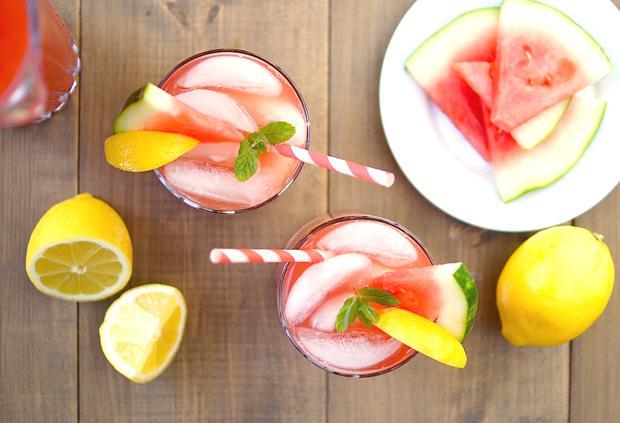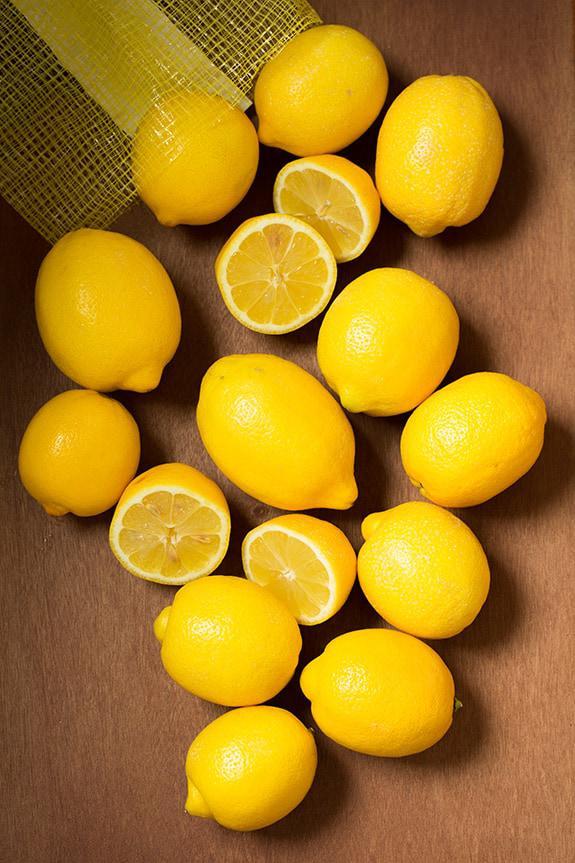The first image is the image on the left, the second image is the image on the right. Considering the images on both sides, is "An image shows glasses garnished with green leaves and watermelon slices." valid? Answer yes or no. Yes. The first image is the image on the left, the second image is the image on the right. For the images displayed, is the sentence "Watermelon slices are pictured with lemons." factually correct? Answer yes or no. Yes. 